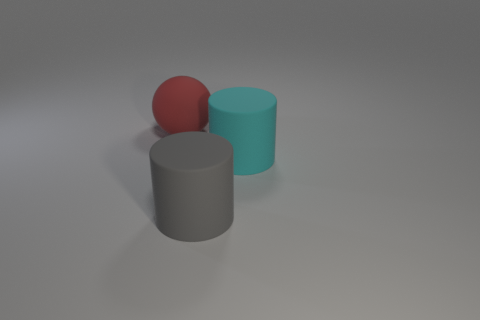How big is the matte object right of the gray cylinder?
Provide a succinct answer. Large. Are there fewer cylinders left of the cyan cylinder than big matte objects that are on the right side of the gray thing?
Your answer should be compact. No. The big thing that is both to the right of the big rubber ball and on the left side of the large cyan thing is made of what material?
Offer a terse response. Rubber. There is a big rubber object on the left side of the large rubber cylinder in front of the cyan matte cylinder; what shape is it?
Your answer should be compact. Sphere. How many blue objects are either big cylinders or spheres?
Provide a short and direct response. 0. There is a large gray cylinder; are there any red balls in front of it?
Make the answer very short. No. What size is the matte sphere?
Your answer should be very brief. Large. What size is the gray matte thing that is the same shape as the big cyan thing?
Provide a succinct answer. Large. How many big rubber spheres are behind the large cylinder in front of the cyan thing?
Keep it short and to the point. 1. Is the big cylinder that is behind the gray rubber thing made of the same material as the ball behind the large gray thing?
Ensure brevity in your answer.  Yes. 